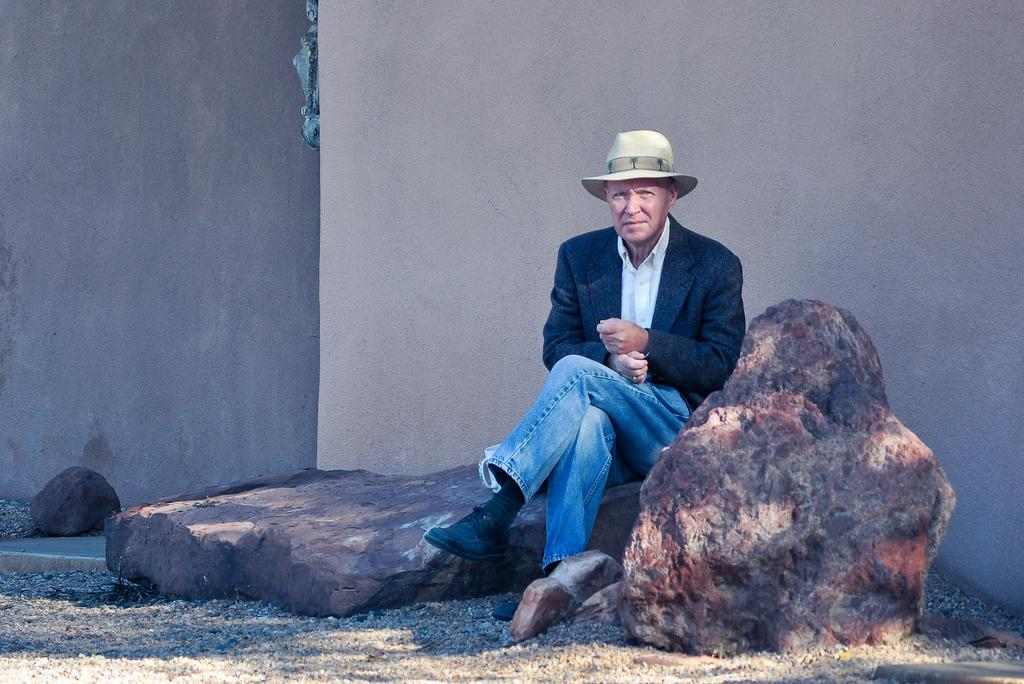What is the person in the image doing? The person is sitting on a rock in the image. What is behind the person in the image? The person is in front of a wall. What is the person wearing? The person is wearing clothes and a hat. Can you describe the landscape in the image? There is another rock in the bottom right of the image. What type of crayon is the person using to draw on the wall in the image? There is no crayon present in the image, and the person is not drawing on the wall. 